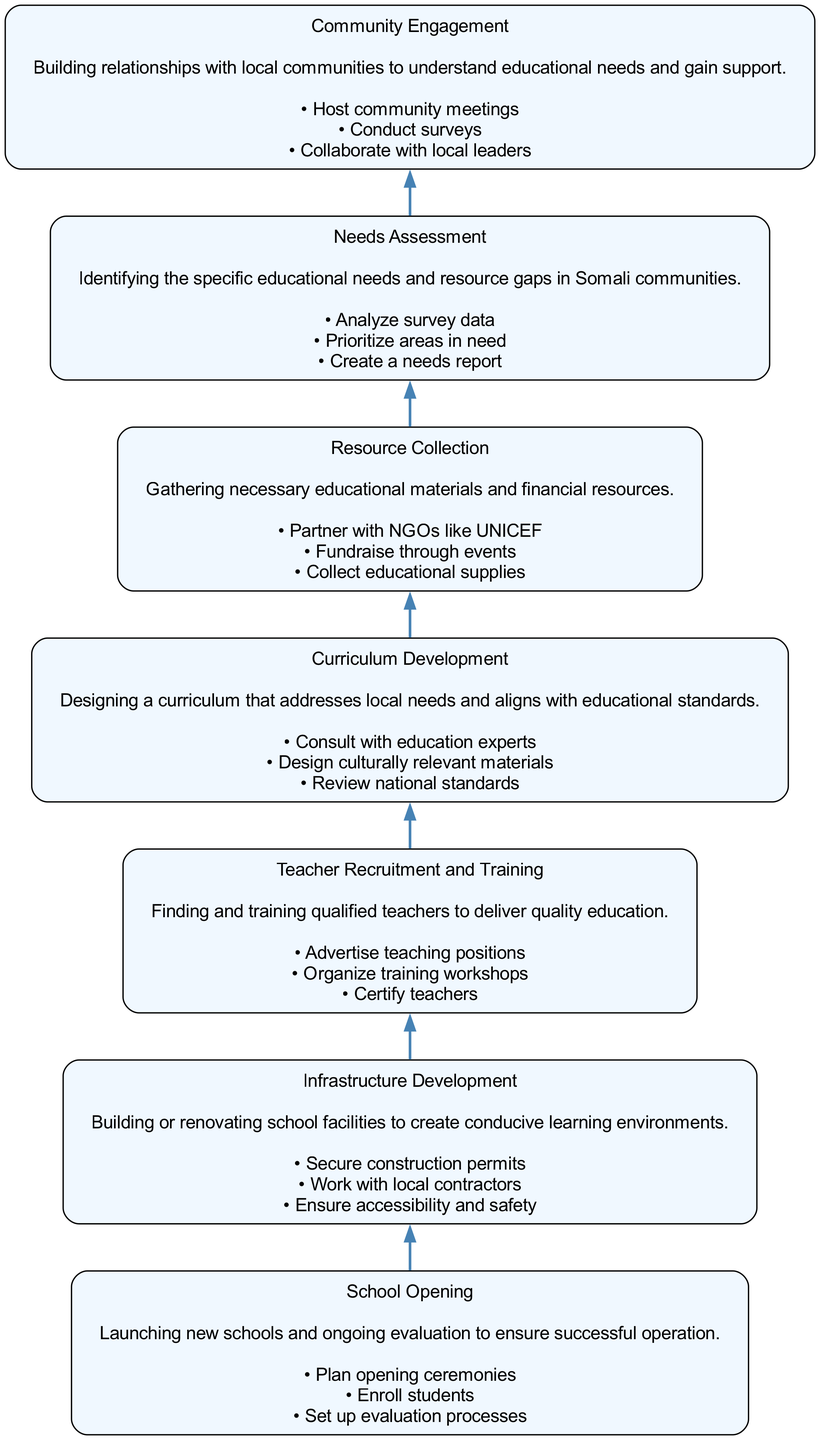What is the first step in the flow chart? The flow chart begins with "Community Engagement," which is the first node at the bottom of the diagram.
Answer: Community Engagement How many actions are listed under "Teacher Recruitment and Training"? The "Teacher Recruitment and Training" node displays three actions: "Advertise teaching positions," "Organize training workshops," and "Certify teachers." Counting these gives a total of three actions.
Answer: 3 What node comes directly after "Resource Collection"? The flow chart shows that after "Resource Collection," the next node is "Curriculum Development," indicating the specific order of steps in the process.
Answer: Curriculum Development What is the last step in the flow chart? The last step in the flow chart, located at the top, is "School Opening," which signifies the final stage in creating educational opportunities.
Answer: School Opening Which action is common in both "Community Engagement" and "Needs Assessment"? The action "Conduct surveys" can be found in "Community Engagement," and is also pertinent to the Needs Assessment, linking both processes in understanding educational needs.
Answer: Conduct surveys What is the relationship between "Curriculum Development" and "Teacher Recruitment and Training"? "Curriculum Development" occurs before "Teacher Recruitment and Training," implying that a well-defined curriculum is essential for recruiting and training teachers suitably.
Answer: Sequential relationship How many total nodes are in the diagram? The diagram contains a total of 7 nodes, each representing a step in the process of creating educational opportunities.
Answer: 7 What action comes before "School Opening"? The action that comes immediately before "School Opening" is "Infrastructure Development," indicating the necessity of having educational facilities ready prior to opening schools.
Answer: Infrastructure Development 